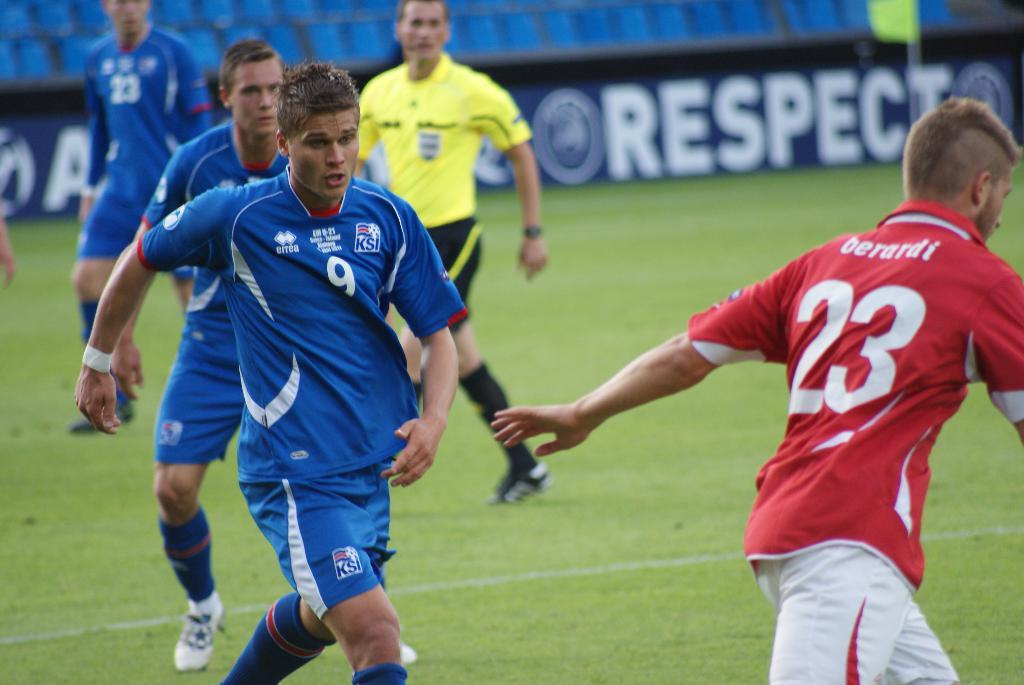Provide a one-sentence caption for the provided image. Some men playing sports; the numbers 23 and 9 are visible. 